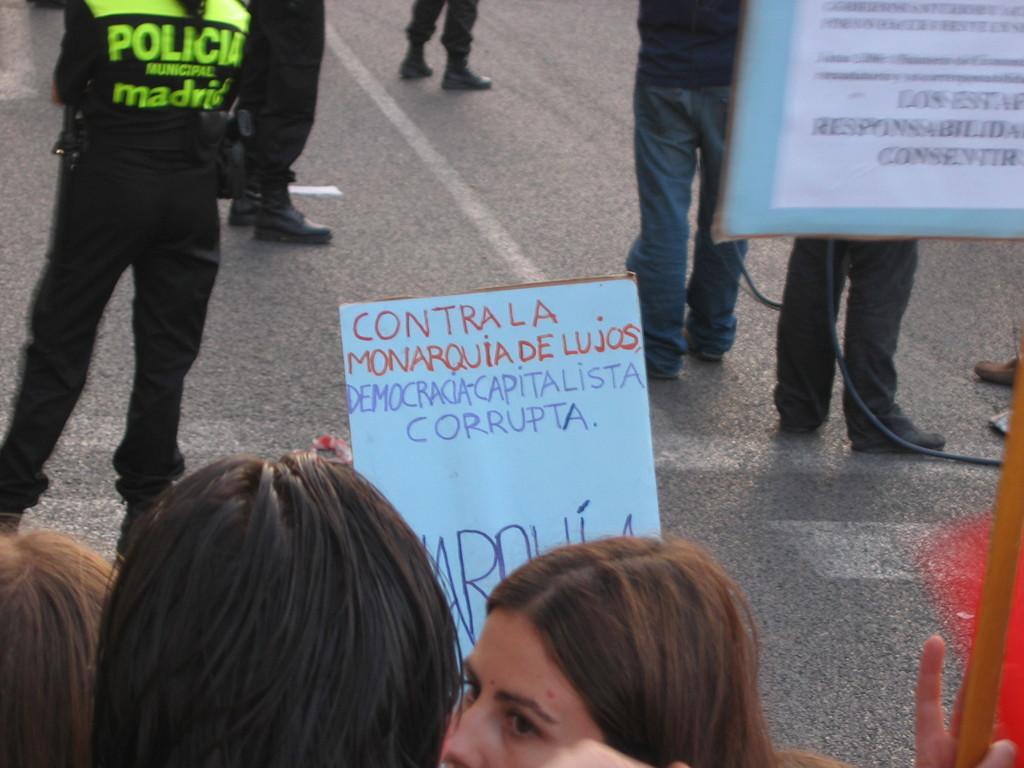Can you describe this image briefly? In this image there are people standing on the road and they are holding the placards. 